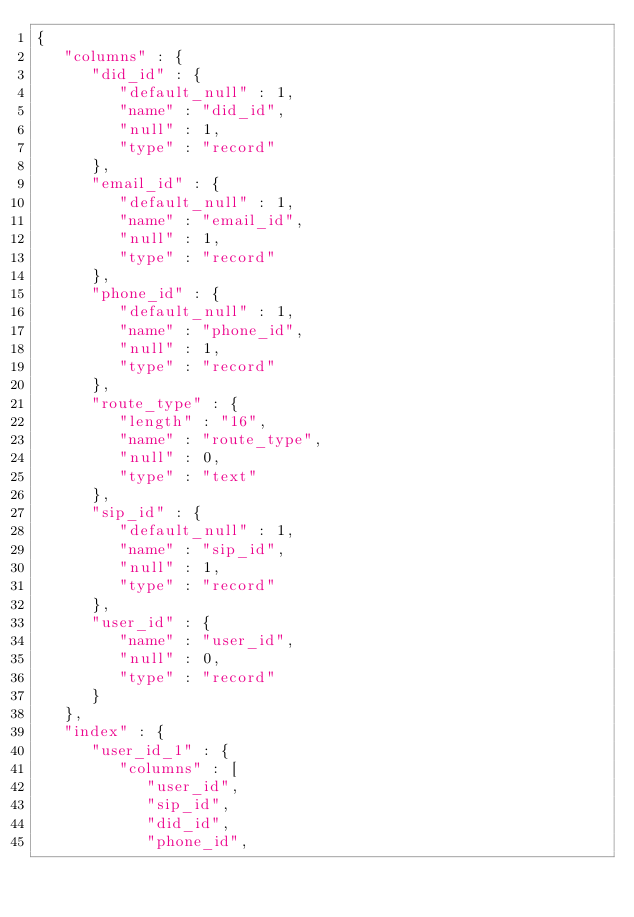Convert code to text. <code><loc_0><loc_0><loc_500><loc_500><_JavaScript_>{
   "columns" : {
      "did_id" : {
         "default_null" : 1,
         "name" : "did_id",
         "null" : 1,
         "type" : "record"
      },
      "email_id" : {
         "default_null" : 1,
         "name" : "email_id",
         "null" : 1,
         "type" : "record"
      },
      "phone_id" : {
         "default_null" : 1,
         "name" : "phone_id",
         "null" : 1,
         "type" : "record"
      },
      "route_type" : {
         "length" : "16",
         "name" : "route_type",
         "null" : 0,
         "type" : "text"
      },
      "sip_id" : {
         "default_null" : 1,
         "name" : "sip_id",
         "null" : 1,
         "type" : "record"
      },
      "user_id" : {
         "name" : "user_id",
         "null" : 0,
         "type" : "record"
      }
   },
   "index" : {
      "user_id_1" : {
         "columns" : [
            "user_id",
            "sip_id",
            "did_id",
            "phone_id",</code> 